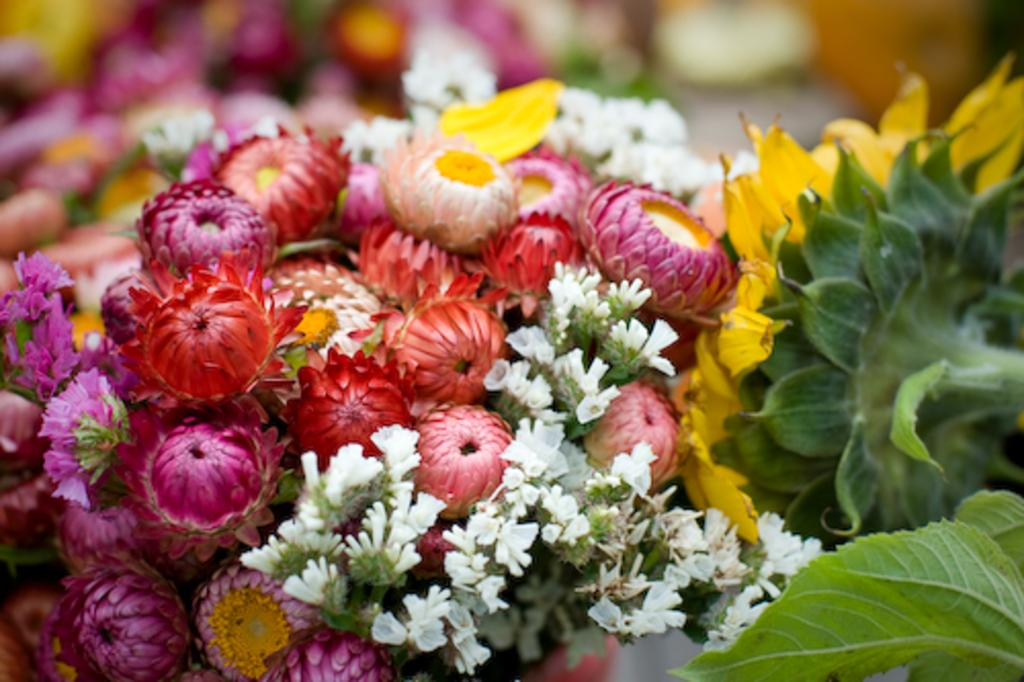What types of plants can be seen in the image? There are different kinds of flowers in the image. What else can be seen on the plants in the image? There are leaves in the image. What can be observed in the background of the image? There are blurred things in the background of the image. What type of doll is sitting on the country road in the image? There is no doll or country road present in the image; it features different kinds of flowers and leaves. 